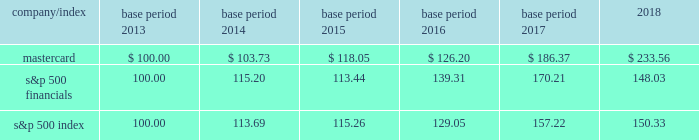Part ii item 5 .
Market for registrant 2019s common equity , related stockholder matters and issuer purchases of equity securities our class a common stock trades on the new york stock exchange under the symbol 201cma 201d .
At february 8 , 2019 , we had 73 stockholders of record for our class a common stock .
We believe that the number of beneficial owners is substantially greater than the number of record holders because a large portion of our class a common stock is held in 201cstreet name 201d by brokers .
There is currently no established public trading market for our class b common stock .
There were approximately 287 holders of record of our non-voting class b common stock as of february 8 , 2019 , constituting approximately 1.1% ( 1.1 % ) of our total outstanding equity .
Stock performance graph the graph and table below compare the cumulative total stockholder return of mastercard 2019s class a common stock , the s&p 500 financials and the s&p 500 index for the five-year period ended december 31 , 2018 .
The graph assumes a $ 100 investment in our class a common stock and both of the indices and the reinvestment of dividends .
Mastercard 2019s class b common stock is not publicly traded or listed on any exchange or dealer quotation system .
Total returns to stockholders for each of the years presented were as follows : indexed returns base period for the years ended december 31 .

As of february 8 , 2019 what was the number of shares outstanding? 
Computations: (287 / 1.1)
Answer: 260.90909. 